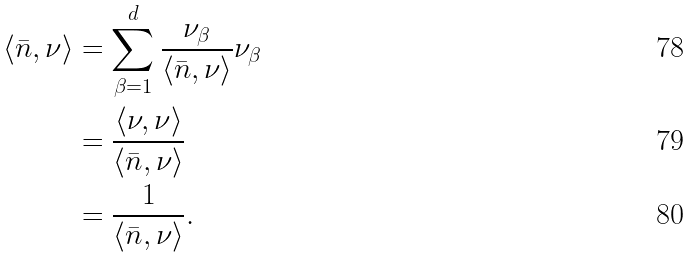<formula> <loc_0><loc_0><loc_500><loc_500>\langle \bar { n } , \nu \rangle & = \sum _ { \beta = 1 } ^ { d } \frac { \nu _ { \beta } } { \langle \bar { n } , \nu \rangle } \nu _ { \beta } \\ & = \frac { \langle \nu , \nu \rangle } { \langle \bar { n } , \nu \rangle } \\ & = \frac { 1 } { \langle \bar { n } , \nu \rangle } .</formula> 